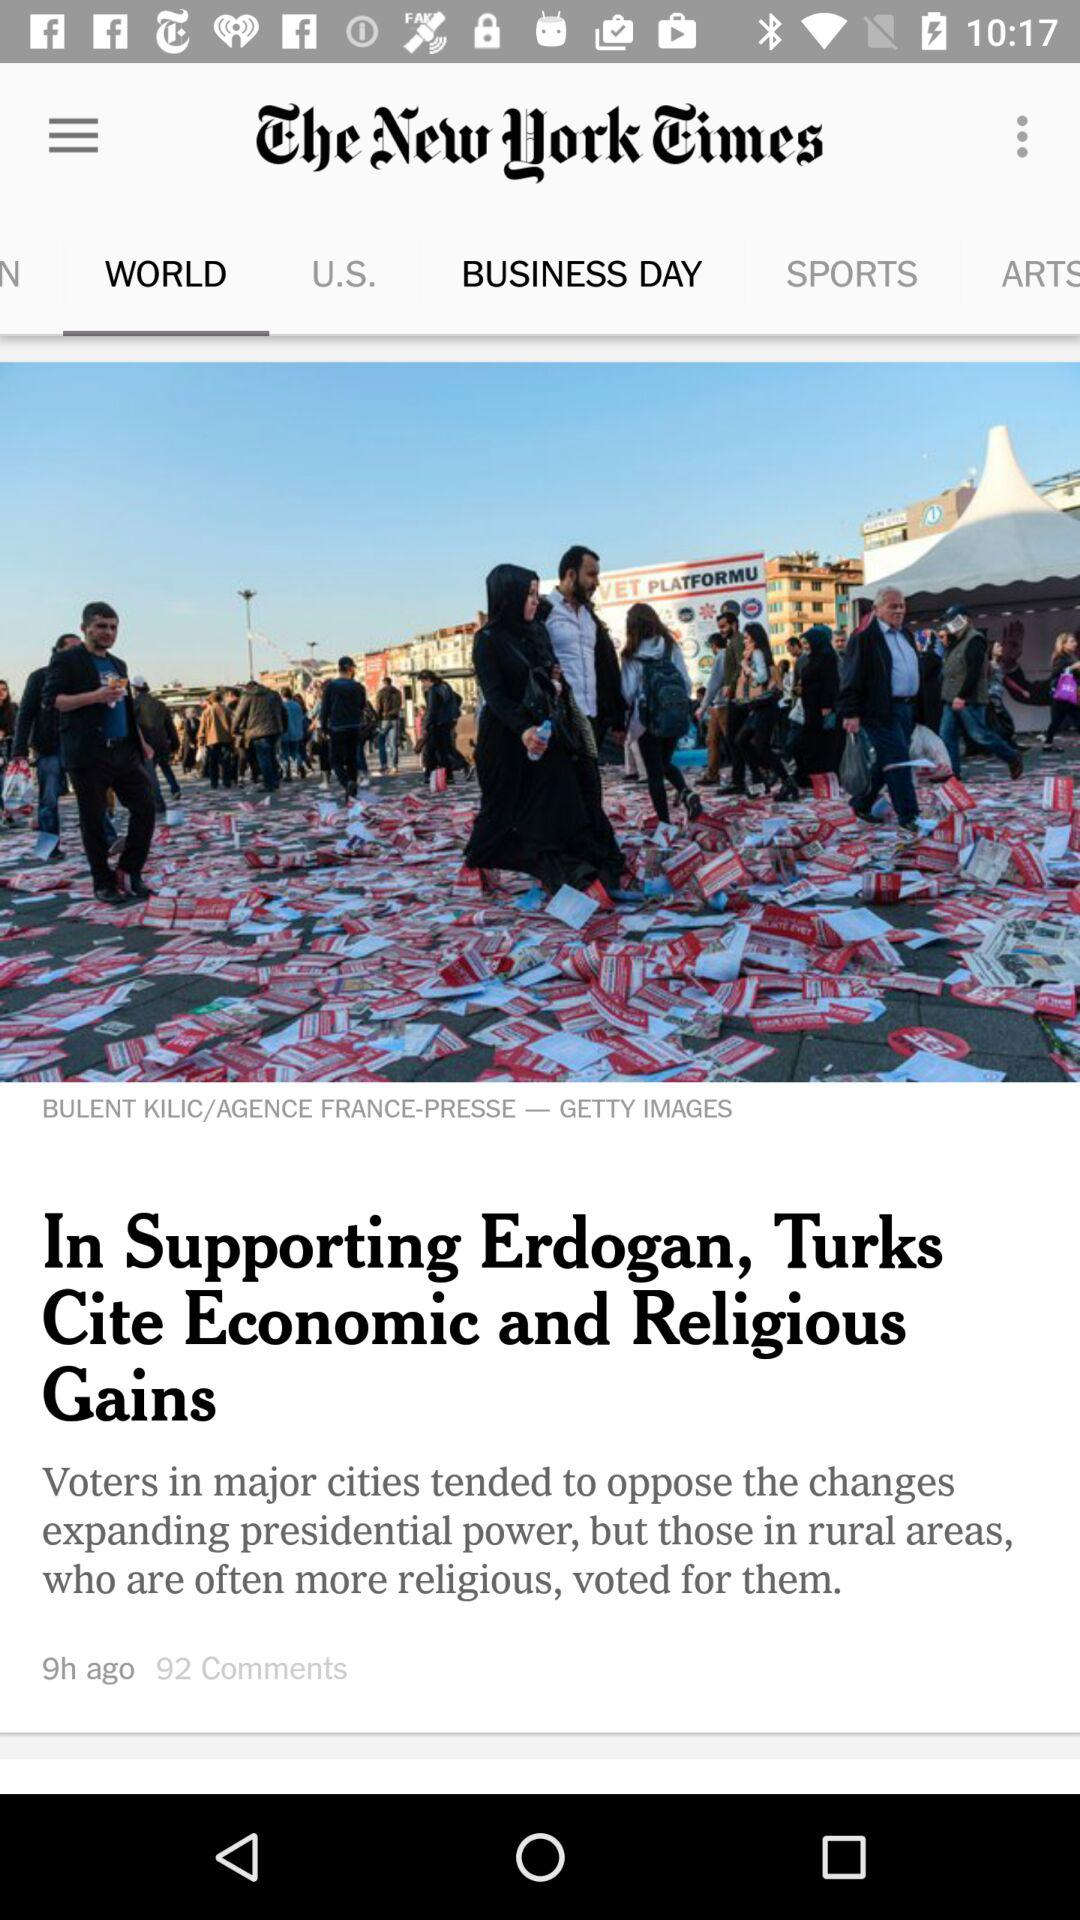What is the count of comments? The count of comments is 92. 